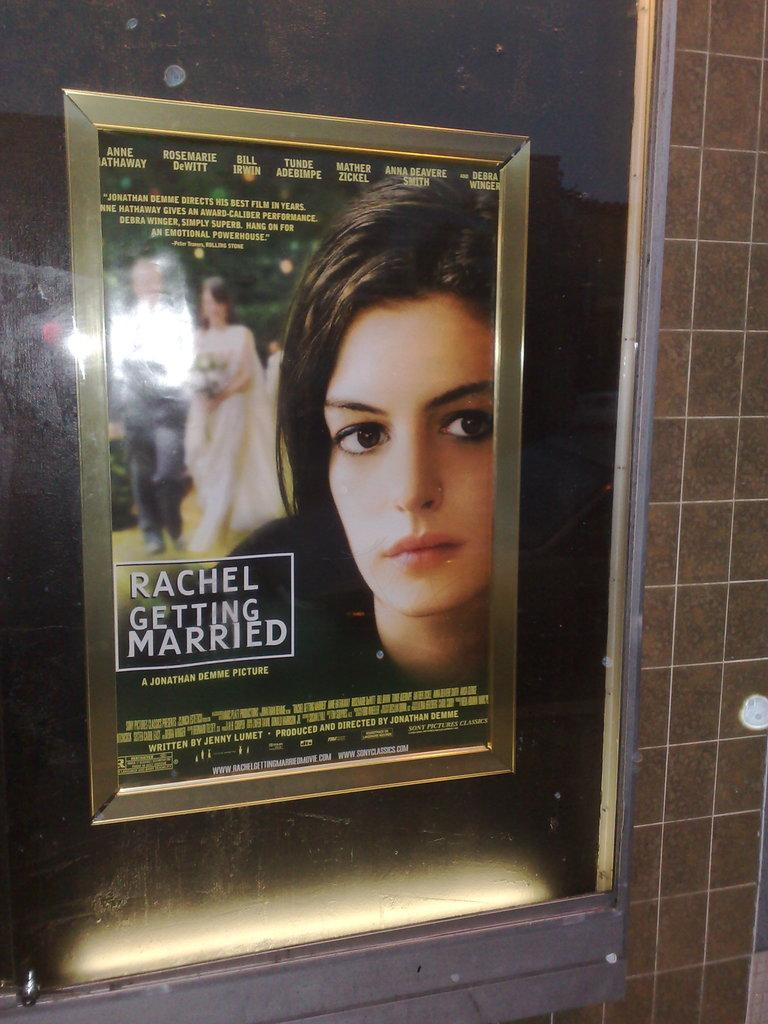What is located in the foreground of the image? There is a glass window in the foreground of the image. What is on the glass window? There is a poster on the window. What can be read on the poster? There is text written on the poster. What is visible on the right side of the image? There is a wall on the right side of the image. How many cakes are being measured on the wall in the image? There are no cakes or measuring tools present in the image. Can you see a rose growing on the wall in the image? There is no rose visible in the image. 